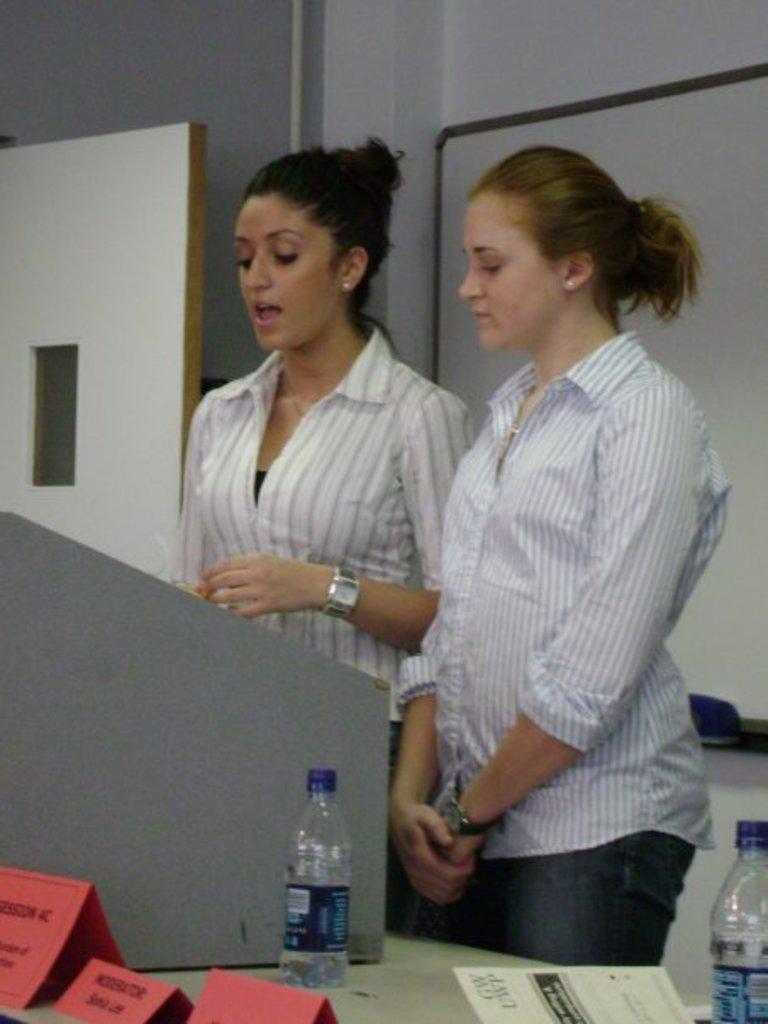In one or two sentences, can you explain what this image depicts? This is a image inside of the room. And there are the two persons standing in front of the table. on the table there is a bottle and there is a paper and a woman wearing a white color shirt and wearing a watch on her hand ,her mouth is open and on the left side there is a door visible and there is a wall ,on the right side there is a bottle 